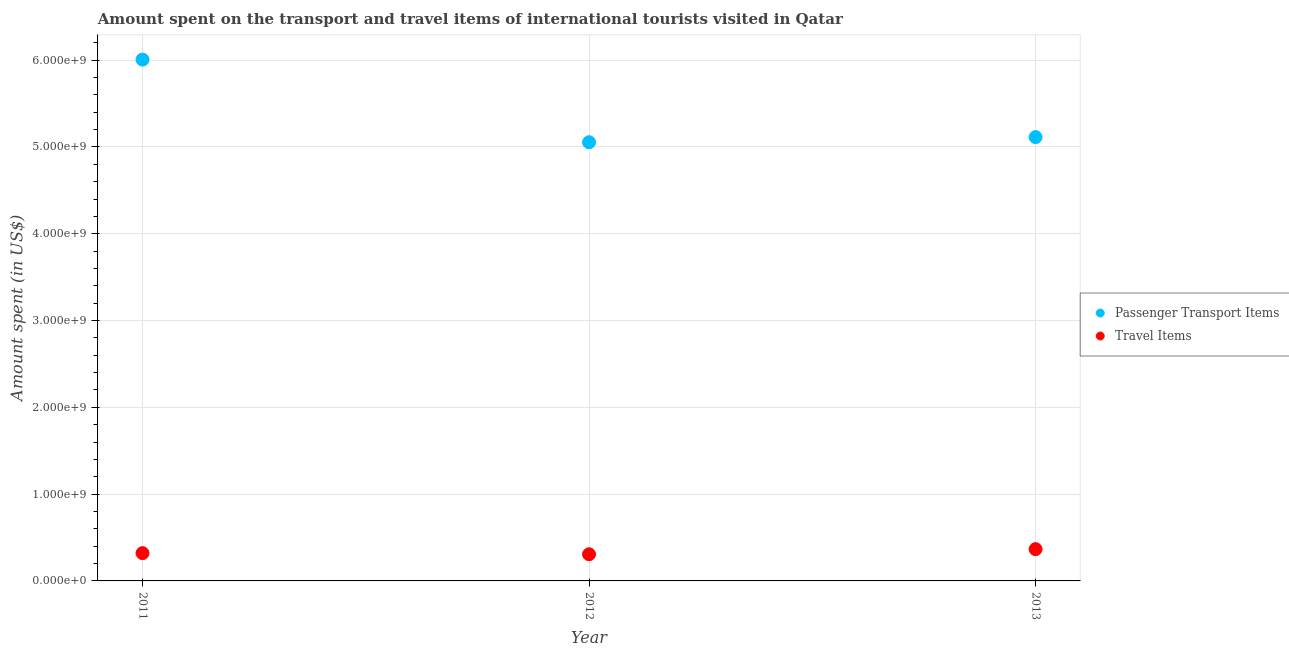How many different coloured dotlines are there?
Keep it short and to the point. 2. What is the amount spent on passenger transport items in 2012?
Offer a very short reply. 5.05e+09. Across all years, what is the maximum amount spent in travel items?
Provide a succinct answer. 3.66e+08. Across all years, what is the minimum amount spent on passenger transport items?
Ensure brevity in your answer.  5.05e+09. What is the total amount spent on passenger transport items in the graph?
Keep it short and to the point. 1.62e+1. What is the difference between the amount spent in travel items in 2011 and that in 2012?
Offer a terse response. 1.30e+07. What is the difference between the amount spent on passenger transport items in 2013 and the amount spent in travel items in 2012?
Your response must be concise. 4.81e+09. What is the average amount spent in travel items per year?
Your answer should be compact. 3.31e+08. In the year 2013, what is the difference between the amount spent in travel items and amount spent on passenger transport items?
Provide a short and direct response. -4.75e+09. In how many years, is the amount spent on passenger transport items greater than 4600000000 US$?
Your response must be concise. 3. What is the ratio of the amount spent in travel items in 2012 to that in 2013?
Keep it short and to the point. 0.84. Is the amount spent in travel items in 2011 less than that in 2013?
Ensure brevity in your answer.  Yes. What is the difference between the highest and the second highest amount spent in travel items?
Your answer should be very brief. 4.60e+07. What is the difference between the highest and the lowest amount spent in travel items?
Ensure brevity in your answer.  5.90e+07. Does the amount spent on passenger transport items monotonically increase over the years?
Provide a succinct answer. No. Is the amount spent on passenger transport items strictly greater than the amount spent in travel items over the years?
Ensure brevity in your answer.  Yes. Is the amount spent on passenger transport items strictly less than the amount spent in travel items over the years?
Offer a terse response. No. How many years are there in the graph?
Your answer should be compact. 3. Does the graph contain grids?
Your answer should be very brief. Yes. How many legend labels are there?
Give a very brief answer. 2. How are the legend labels stacked?
Offer a terse response. Vertical. What is the title of the graph?
Your response must be concise. Amount spent on the transport and travel items of international tourists visited in Qatar. Does "Exports of goods" appear as one of the legend labels in the graph?
Provide a short and direct response. No. What is the label or title of the X-axis?
Your answer should be compact. Year. What is the label or title of the Y-axis?
Provide a short and direct response. Amount spent (in US$). What is the Amount spent (in US$) in Passenger Transport Items in 2011?
Give a very brief answer. 6.01e+09. What is the Amount spent (in US$) of Travel Items in 2011?
Ensure brevity in your answer.  3.20e+08. What is the Amount spent (in US$) in Passenger Transport Items in 2012?
Your response must be concise. 5.05e+09. What is the Amount spent (in US$) of Travel Items in 2012?
Keep it short and to the point. 3.07e+08. What is the Amount spent (in US$) in Passenger Transport Items in 2013?
Offer a very short reply. 5.11e+09. What is the Amount spent (in US$) in Travel Items in 2013?
Offer a very short reply. 3.66e+08. Across all years, what is the maximum Amount spent (in US$) in Passenger Transport Items?
Your response must be concise. 6.01e+09. Across all years, what is the maximum Amount spent (in US$) in Travel Items?
Give a very brief answer. 3.66e+08. Across all years, what is the minimum Amount spent (in US$) of Passenger Transport Items?
Your response must be concise. 5.05e+09. Across all years, what is the minimum Amount spent (in US$) in Travel Items?
Your answer should be compact. 3.07e+08. What is the total Amount spent (in US$) in Passenger Transport Items in the graph?
Provide a succinct answer. 1.62e+1. What is the total Amount spent (in US$) in Travel Items in the graph?
Keep it short and to the point. 9.93e+08. What is the difference between the Amount spent (in US$) in Passenger Transport Items in 2011 and that in 2012?
Your response must be concise. 9.52e+08. What is the difference between the Amount spent (in US$) in Travel Items in 2011 and that in 2012?
Make the answer very short. 1.30e+07. What is the difference between the Amount spent (in US$) of Passenger Transport Items in 2011 and that in 2013?
Make the answer very short. 8.93e+08. What is the difference between the Amount spent (in US$) in Travel Items in 2011 and that in 2013?
Offer a very short reply. -4.60e+07. What is the difference between the Amount spent (in US$) in Passenger Transport Items in 2012 and that in 2013?
Your response must be concise. -5.90e+07. What is the difference between the Amount spent (in US$) in Travel Items in 2012 and that in 2013?
Provide a succinct answer. -5.90e+07. What is the difference between the Amount spent (in US$) in Passenger Transport Items in 2011 and the Amount spent (in US$) in Travel Items in 2012?
Make the answer very short. 5.70e+09. What is the difference between the Amount spent (in US$) in Passenger Transport Items in 2011 and the Amount spent (in US$) in Travel Items in 2013?
Your response must be concise. 5.64e+09. What is the difference between the Amount spent (in US$) in Passenger Transport Items in 2012 and the Amount spent (in US$) in Travel Items in 2013?
Your answer should be compact. 4.69e+09. What is the average Amount spent (in US$) of Passenger Transport Items per year?
Offer a very short reply. 5.39e+09. What is the average Amount spent (in US$) of Travel Items per year?
Provide a short and direct response. 3.31e+08. In the year 2011, what is the difference between the Amount spent (in US$) of Passenger Transport Items and Amount spent (in US$) of Travel Items?
Keep it short and to the point. 5.69e+09. In the year 2012, what is the difference between the Amount spent (in US$) of Passenger Transport Items and Amount spent (in US$) of Travel Items?
Make the answer very short. 4.75e+09. In the year 2013, what is the difference between the Amount spent (in US$) of Passenger Transport Items and Amount spent (in US$) of Travel Items?
Your answer should be very brief. 4.75e+09. What is the ratio of the Amount spent (in US$) in Passenger Transport Items in 2011 to that in 2012?
Offer a very short reply. 1.19. What is the ratio of the Amount spent (in US$) in Travel Items in 2011 to that in 2012?
Give a very brief answer. 1.04. What is the ratio of the Amount spent (in US$) of Passenger Transport Items in 2011 to that in 2013?
Make the answer very short. 1.17. What is the ratio of the Amount spent (in US$) of Travel Items in 2011 to that in 2013?
Give a very brief answer. 0.87. What is the ratio of the Amount spent (in US$) of Passenger Transport Items in 2012 to that in 2013?
Your answer should be very brief. 0.99. What is the ratio of the Amount spent (in US$) of Travel Items in 2012 to that in 2013?
Your answer should be very brief. 0.84. What is the difference between the highest and the second highest Amount spent (in US$) of Passenger Transport Items?
Provide a short and direct response. 8.93e+08. What is the difference between the highest and the second highest Amount spent (in US$) of Travel Items?
Your answer should be compact. 4.60e+07. What is the difference between the highest and the lowest Amount spent (in US$) in Passenger Transport Items?
Provide a succinct answer. 9.52e+08. What is the difference between the highest and the lowest Amount spent (in US$) in Travel Items?
Offer a terse response. 5.90e+07. 